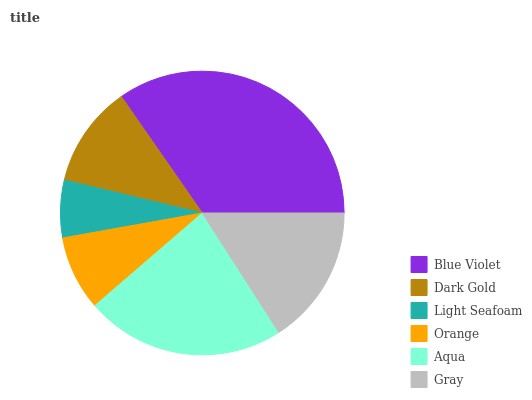Is Light Seafoam the minimum?
Answer yes or no. Yes. Is Blue Violet the maximum?
Answer yes or no. Yes. Is Dark Gold the minimum?
Answer yes or no. No. Is Dark Gold the maximum?
Answer yes or no. No. Is Blue Violet greater than Dark Gold?
Answer yes or no. Yes. Is Dark Gold less than Blue Violet?
Answer yes or no. Yes. Is Dark Gold greater than Blue Violet?
Answer yes or no. No. Is Blue Violet less than Dark Gold?
Answer yes or no. No. Is Gray the high median?
Answer yes or no. Yes. Is Dark Gold the low median?
Answer yes or no. Yes. Is Aqua the high median?
Answer yes or no. No. Is Gray the low median?
Answer yes or no. No. 